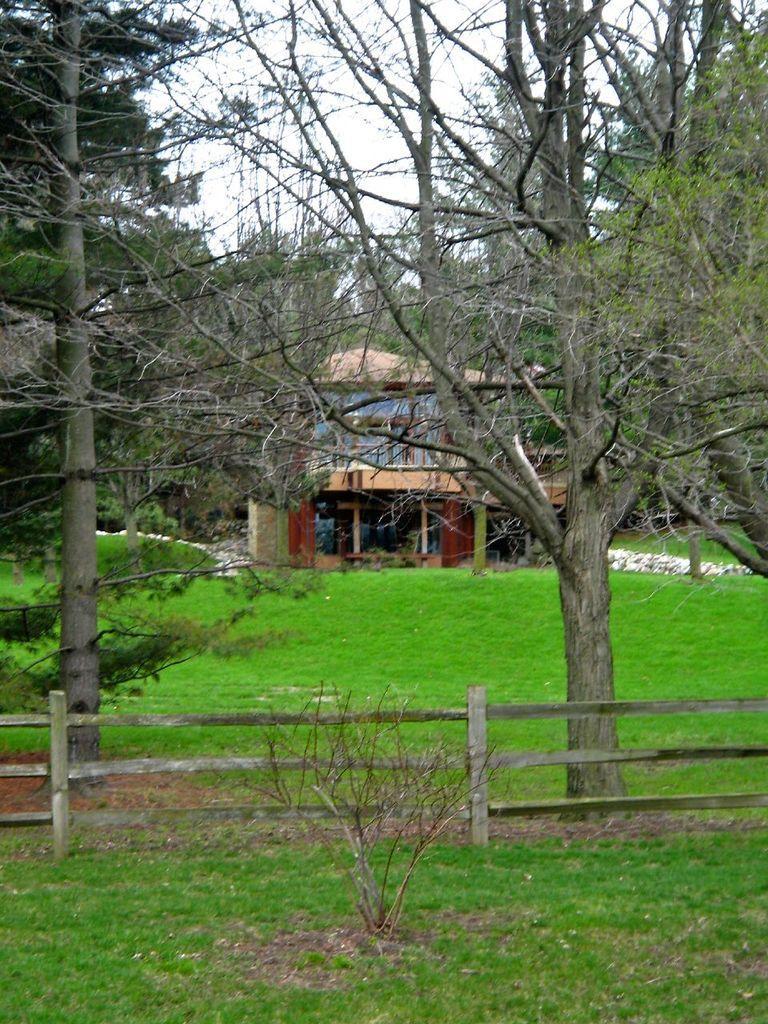Describe this image in one or two sentences. In this image there is grass on the ground. There is a wooden fence in the front. In the background there are trees, there is a building and the sky is cloudy. 